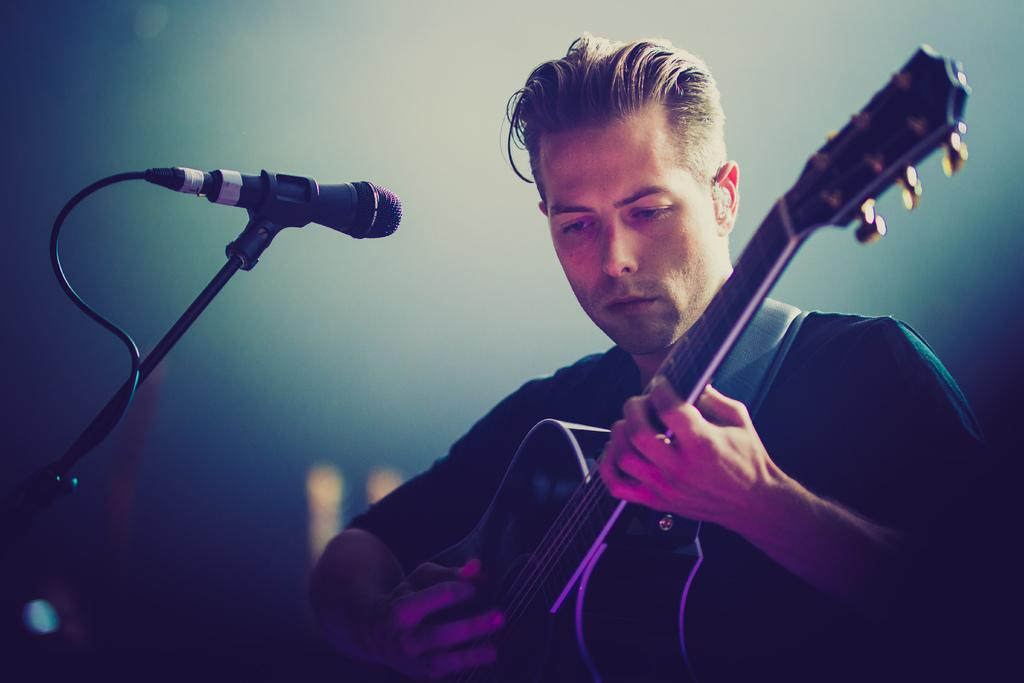Who is present in the image? There is a boy in the image. Where is the boy located in the image? The boy is at the right side of the image. What is the boy holding in his hands? The boy is holding a guitar in his hands. What other object can be seen in the image? There is a microphone in the image. Where is the microphone located in the image? The microphone is at the left side of the image. What type of mark can be seen on the boy's forehead in the image? There is no mark visible on the boy's forehead in the image. What nation is represented by the boy in the image? The image does not provide any information about the boy's nationality or the nation he represents. 